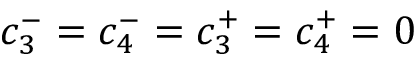<formula> <loc_0><loc_0><loc_500><loc_500>c _ { 3 } ^ { - } = c _ { 4 } ^ { - } = c _ { 3 } ^ { + } = c _ { 4 } ^ { + } = 0</formula> 